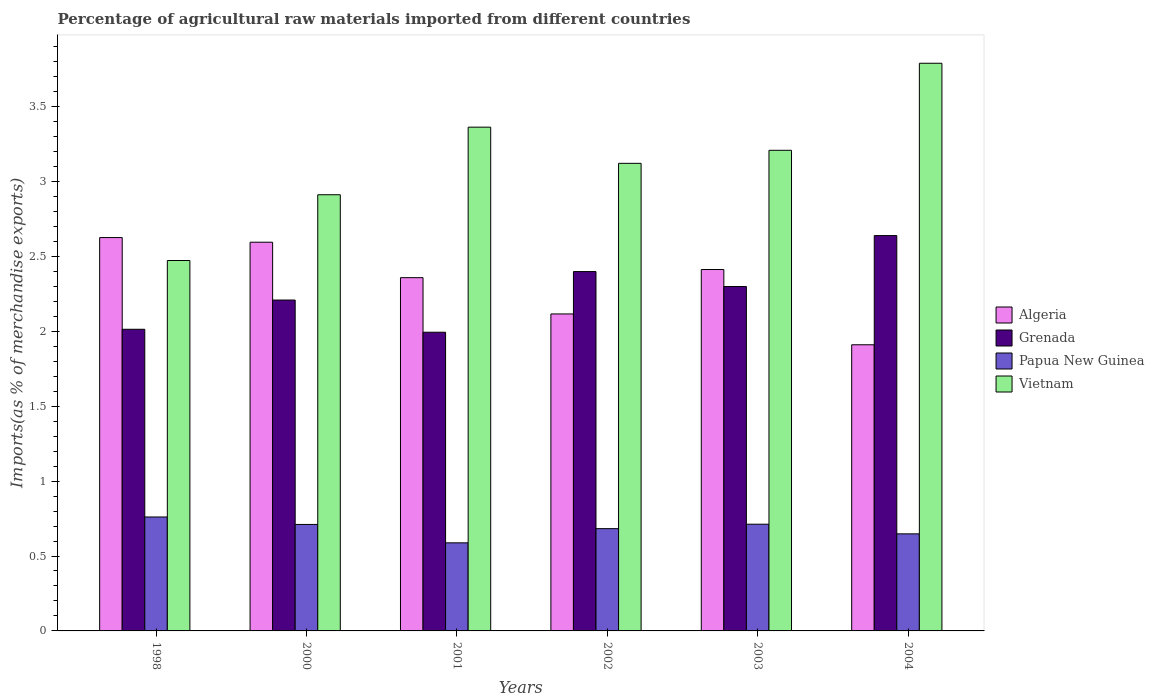How many groups of bars are there?
Provide a succinct answer. 6. Are the number of bars per tick equal to the number of legend labels?
Your response must be concise. Yes. How many bars are there on the 4th tick from the left?
Make the answer very short. 4. What is the label of the 1st group of bars from the left?
Provide a short and direct response. 1998. What is the percentage of imports to different countries in Grenada in 2004?
Keep it short and to the point. 2.64. Across all years, what is the maximum percentage of imports to different countries in Algeria?
Offer a terse response. 2.63. Across all years, what is the minimum percentage of imports to different countries in Vietnam?
Make the answer very short. 2.47. In which year was the percentage of imports to different countries in Papua New Guinea minimum?
Give a very brief answer. 2001. What is the total percentage of imports to different countries in Vietnam in the graph?
Keep it short and to the point. 18.86. What is the difference between the percentage of imports to different countries in Grenada in 2002 and that in 2004?
Offer a terse response. -0.24. What is the difference between the percentage of imports to different countries in Grenada in 2000 and the percentage of imports to different countries in Algeria in 2003?
Your answer should be compact. -0.2. What is the average percentage of imports to different countries in Algeria per year?
Provide a short and direct response. 2.34. In the year 2004, what is the difference between the percentage of imports to different countries in Papua New Guinea and percentage of imports to different countries in Grenada?
Offer a very short reply. -1.99. In how many years, is the percentage of imports to different countries in Papua New Guinea greater than 2.1 %?
Make the answer very short. 0. What is the ratio of the percentage of imports to different countries in Papua New Guinea in 2000 to that in 2002?
Ensure brevity in your answer.  1.04. Is the difference between the percentage of imports to different countries in Papua New Guinea in 1998 and 2002 greater than the difference between the percentage of imports to different countries in Grenada in 1998 and 2002?
Your answer should be compact. Yes. What is the difference between the highest and the second highest percentage of imports to different countries in Papua New Guinea?
Your answer should be very brief. 0.05. What is the difference between the highest and the lowest percentage of imports to different countries in Vietnam?
Keep it short and to the point. 1.32. What does the 3rd bar from the left in 1998 represents?
Your response must be concise. Papua New Guinea. What does the 1st bar from the right in 2001 represents?
Your answer should be compact. Vietnam. How many bars are there?
Keep it short and to the point. 24. How many years are there in the graph?
Offer a terse response. 6. Are the values on the major ticks of Y-axis written in scientific E-notation?
Ensure brevity in your answer.  No. How many legend labels are there?
Provide a short and direct response. 4. How are the legend labels stacked?
Provide a short and direct response. Vertical. What is the title of the graph?
Your response must be concise. Percentage of agricultural raw materials imported from different countries. What is the label or title of the Y-axis?
Your answer should be very brief. Imports(as % of merchandise exports). What is the Imports(as % of merchandise exports) in Algeria in 1998?
Your response must be concise. 2.63. What is the Imports(as % of merchandise exports) of Grenada in 1998?
Your response must be concise. 2.01. What is the Imports(as % of merchandise exports) of Papua New Guinea in 1998?
Give a very brief answer. 0.76. What is the Imports(as % of merchandise exports) of Vietnam in 1998?
Offer a terse response. 2.47. What is the Imports(as % of merchandise exports) in Algeria in 2000?
Offer a terse response. 2.59. What is the Imports(as % of merchandise exports) in Grenada in 2000?
Your answer should be compact. 2.21. What is the Imports(as % of merchandise exports) in Papua New Guinea in 2000?
Your answer should be very brief. 0.71. What is the Imports(as % of merchandise exports) of Vietnam in 2000?
Offer a very short reply. 2.91. What is the Imports(as % of merchandise exports) in Algeria in 2001?
Make the answer very short. 2.36. What is the Imports(as % of merchandise exports) of Grenada in 2001?
Provide a short and direct response. 1.99. What is the Imports(as % of merchandise exports) of Papua New Guinea in 2001?
Your response must be concise. 0.59. What is the Imports(as % of merchandise exports) in Vietnam in 2001?
Offer a terse response. 3.36. What is the Imports(as % of merchandise exports) of Algeria in 2002?
Provide a short and direct response. 2.12. What is the Imports(as % of merchandise exports) in Grenada in 2002?
Your answer should be very brief. 2.4. What is the Imports(as % of merchandise exports) in Papua New Guinea in 2002?
Your answer should be very brief. 0.68. What is the Imports(as % of merchandise exports) in Vietnam in 2002?
Keep it short and to the point. 3.12. What is the Imports(as % of merchandise exports) of Algeria in 2003?
Offer a terse response. 2.41. What is the Imports(as % of merchandise exports) of Grenada in 2003?
Your answer should be very brief. 2.3. What is the Imports(as % of merchandise exports) in Papua New Guinea in 2003?
Ensure brevity in your answer.  0.71. What is the Imports(as % of merchandise exports) of Vietnam in 2003?
Your answer should be very brief. 3.21. What is the Imports(as % of merchandise exports) in Algeria in 2004?
Your response must be concise. 1.91. What is the Imports(as % of merchandise exports) of Grenada in 2004?
Your answer should be very brief. 2.64. What is the Imports(as % of merchandise exports) in Papua New Guinea in 2004?
Offer a terse response. 0.65. What is the Imports(as % of merchandise exports) of Vietnam in 2004?
Give a very brief answer. 3.79. Across all years, what is the maximum Imports(as % of merchandise exports) in Algeria?
Your answer should be compact. 2.63. Across all years, what is the maximum Imports(as % of merchandise exports) in Grenada?
Give a very brief answer. 2.64. Across all years, what is the maximum Imports(as % of merchandise exports) of Papua New Guinea?
Your answer should be very brief. 0.76. Across all years, what is the maximum Imports(as % of merchandise exports) in Vietnam?
Your answer should be compact. 3.79. Across all years, what is the minimum Imports(as % of merchandise exports) in Algeria?
Give a very brief answer. 1.91. Across all years, what is the minimum Imports(as % of merchandise exports) of Grenada?
Offer a terse response. 1.99. Across all years, what is the minimum Imports(as % of merchandise exports) of Papua New Guinea?
Offer a very short reply. 0.59. Across all years, what is the minimum Imports(as % of merchandise exports) in Vietnam?
Offer a terse response. 2.47. What is the total Imports(as % of merchandise exports) in Algeria in the graph?
Your answer should be compact. 14.01. What is the total Imports(as % of merchandise exports) in Grenada in the graph?
Offer a terse response. 13.55. What is the total Imports(as % of merchandise exports) of Papua New Guinea in the graph?
Provide a short and direct response. 4.1. What is the total Imports(as % of merchandise exports) in Vietnam in the graph?
Keep it short and to the point. 18.86. What is the difference between the Imports(as % of merchandise exports) of Algeria in 1998 and that in 2000?
Offer a very short reply. 0.03. What is the difference between the Imports(as % of merchandise exports) in Grenada in 1998 and that in 2000?
Make the answer very short. -0.2. What is the difference between the Imports(as % of merchandise exports) in Papua New Guinea in 1998 and that in 2000?
Make the answer very short. 0.05. What is the difference between the Imports(as % of merchandise exports) of Vietnam in 1998 and that in 2000?
Offer a very short reply. -0.44. What is the difference between the Imports(as % of merchandise exports) of Algeria in 1998 and that in 2001?
Provide a succinct answer. 0.27. What is the difference between the Imports(as % of merchandise exports) of Grenada in 1998 and that in 2001?
Your answer should be very brief. 0.02. What is the difference between the Imports(as % of merchandise exports) in Papua New Guinea in 1998 and that in 2001?
Make the answer very short. 0.17. What is the difference between the Imports(as % of merchandise exports) of Vietnam in 1998 and that in 2001?
Provide a succinct answer. -0.89. What is the difference between the Imports(as % of merchandise exports) in Algeria in 1998 and that in 2002?
Offer a terse response. 0.51. What is the difference between the Imports(as % of merchandise exports) in Grenada in 1998 and that in 2002?
Ensure brevity in your answer.  -0.39. What is the difference between the Imports(as % of merchandise exports) of Papua New Guinea in 1998 and that in 2002?
Offer a terse response. 0.08. What is the difference between the Imports(as % of merchandise exports) of Vietnam in 1998 and that in 2002?
Offer a very short reply. -0.65. What is the difference between the Imports(as % of merchandise exports) in Algeria in 1998 and that in 2003?
Ensure brevity in your answer.  0.21. What is the difference between the Imports(as % of merchandise exports) of Grenada in 1998 and that in 2003?
Provide a short and direct response. -0.29. What is the difference between the Imports(as % of merchandise exports) in Papua New Guinea in 1998 and that in 2003?
Give a very brief answer. 0.05. What is the difference between the Imports(as % of merchandise exports) in Vietnam in 1998 and that in 2003?
Your response must be concise. -0.74. What is the difference between the Imports(as % of merchandise exports) in Algeria in 1998 and that in 2004?
Your response must be concise. 0.72. What is the difference between the Imports(as % of merchandise exports) of Grenada in 1998 and that in 2004?
Give a very brief answer. -0.63. What is the difference between the Imports(as % of merchandise exports) of Papua New Guinea in 1998 and that in 2004?
Make the answer very short. 0.11. What is the difference between the Imports(as % of merchandise exports) in Vietnam in 1998 and that in 2004?
Offer a very short reply. -1.32. What is the difference between the Imports(as % of merchandise exports) of Algeria in 2000 and that in 2001?
Ensure brevity in your answer.  0.24. What is the difference between the Imports(as % of merchandise exports) of Grenada in 2000 and that in 2001?
Keep it short and to the point. 0.21. What is the difference between the Imports(as % of merchandise exports) in Papua New Guinea in 2000 and that in 2001?
Your answer should be compact. 0.12. What is the difference between the Imports(as % of merchandise exports) in Vietnam in 2000 and that in 2001?
Your answer should be compact. -0.45. What is the difference between the Imports(as % of merchandise exports) in Algeria in 2000 and that in 2002?
Give a very brief answer. 0.48. What is the difference between the Imports(as % of merchandise exports) of Grenada in 2000 and that in 2002?
Provide a succinct answer. -0.19. What is the difference between the Imports(as % of merchandise exports) of Papua New Guinea in 2000 and that in 2002?
Your response must be concise. 0.03. What is the difference between the Imports(as % of merchandise exports) of Vietnam in 2000 and that in 2002?
Make the answer very short. -0.21. What is the difference between the Imports(as % of merchandise exports) of Algeria in 2000 and that in 2003?
Keep it short and to the point. 0.18. What is the difference between the Imports(as % of merchandise exports) of Grenada in 2000 and that in 2003?
Keep it short and to the point. -0.09. What is the difference between the Imports(as % of merchandise exports) of Papua New Guinea in 2000 and that in 2003?
Keep it short and to the point. -0. What is the difference between the Imports(as % of merchandise exports) of Vietnam in 2000 and that in 2003?
Your response must be concise. -0.3. What is the difference between the Imports(as % of merchandise exports) of Algeria in 2000 and that in 2004?
Keep it short and to the point. 0.68. What is the difference between the Imports(as % of merchandise exports) of Grenada in 2000 and that in 2004?
Make the answer very short. -0.43. What is the difference between the Imports(as % of merchandise exports) of Papua New Guinea in 2000 and that in 2004?
Keep it short and to the point. 0.06. What is the difference between the Imports(as % of merchandise exports) in Vietnam in 2000 and that in 2004?
Your response must be concise. -0.88. What is the difference between the Imports(as % of merchandise exports) of Algeria in 2001 and that in 2002?
Ensure brevity in your answer.  0.24. What is the difference between the Imports(as % of merchandise exports) of Grenada in 2001 and that in 2002?
Your answer should be compact. -0.4. What is the difference between the Imports(as % of merchandise exports) of Papua New Guinea in 2001 and that in 2002?
Your answer should be compact. -0.09. What is the difference between the Imports(as % of merchandise exports) of Vietnam in 2001 and that in 2002?
Ensure brevity in your answer.  0.24. What is the difference between the Imports(as % of merchandise exports) of Algeria in 2001 and that in 2003?
Ensure brevity in your answer.  -0.05. What is the difference between the Imports(as % of merchandise exports) in Grenada in 2001 and that in 2003?
Provide a short and direct response. -0.31. What is the difference between the Imports(as % of merchandise exports) of Papua New Guinea in 2001 and that in 2003?
Your answer should be very brief. -0.12. What is the difference between the Imports(as % of merchandise exports) of Vietnam in 2001 and that in 2003?
Offer a terse response. 0.15. What is the difference between the Imports(as % of merchandise exports) in Algeria in 2001 and that in 2004?
Your response must be concise. 0.45. What is the difference between the Imports(as % of merchandise exports) in Grenada in 2001 and that in 2004?
Provide a short and direct response. -0.65. What is the difference between the Imports(as % of merchandise exports) in Papua New Guinea in 2001 and that in 2004?
Provide a succinct answer. -0.06. What is the difference between the Imports(as % of merchandise exports) in Vietnam in 2001 and that in 2004?
Offer a terse response. -0.43. What is the difference between the Imports(as % of merchandise exports) in Algeria in 2002 and that in 2003?
Your response must be concise. -0.3. What is the difference between the Imports(as % of merchandise exports) in Grenada in 2002 and that in 2003?
Your answer should be very brief. 0.1. What is the difference between the Imports(as % of merchandise exports) of Papua New Guinea in 2002 and that in 2003?
Make the answer very short. -0.03. What is the difference between the Imports(as % of merchandise exports) in Vietnam in 2002 and that in 2003?
Provide a short and direct response. -0.09. What is the difference between the Imports(as % of merchandise exports) of Algeria in 2002 and that in 2004?
Your answer should be compact. 0.21. What is the difference between the Imports(as % of merchandise exports) of Grenada in 2002 and that in 2004?
Offer a very short reply. -0.24. What is the difference between the Imports(as % of merchandise exports) in Papua New Guinea in 2002 and that in 2004?
Your response must be concise. 0.03. What is the difference between the Imports(as % of merchandise exports) of Vietnam in 2002 and that in 2004?
Provide a succinct answer. -0.67. What is the difference between the Imports(as % of merchandise exports) in Algeria in 2003 and that in 2004?
Offer a terse response. 0.5. What is the difference between the Imports(as % of merchandise exports) in Grenada in 2003 and that in 2004?
Your answer should be very brief. -0.34. What is the difference between the Imports(as % of merchandise exports) of Papua New Guinea in 2003 and that in 2004?
Give a very brief answer. 0.06. What is the difference between the Imports(as % of merchandise exports) of Vietnam in 2003 and that in 2004?
Offer a terse response. -0.58. What is the difference between the Imports(as % of merchandise exports) in Algeria in 1998 and the Imports(as % of merchandise exports) in Grenada in 2000?
Provide a succinct answer. 0.42. What is the difference between the Imports(as % of merchandise exports) in Algeria in 1998 and the Imports(as % of merchandise exports) in Papua New Guinea in 2000?
Provide a succinct answer. 1.91. What is the difference between the Imports(as % of merchandise exports) of Algeria in 1998 and the Imports(as % of merchandise exports) of Vietnam in 2000?
Your answer should be very brief. -0.29. What is the difference between the Imports(as % of merchandise exports) of Grenada in 1998 and the Imports(as % of merchandise exports) of Papua New Guinea in 2000?
Ensure brevity in your answer.  1.3. What is the difference between the Imports(as % of merchandise exports) of Grenada in 1998 and the Imports(as % of merchandise exports) of Vietnam in 2000?
Give a very brief answer. -0.9. What is the difference between the Imports(as % of merchandise exports) in Papua New Guinea in 1998 and the Imports(as % of merchandise exports) in Vietnam in 2000?
Offer a terse response. -2.15. What is the difference between the Imports(as % of merchandise exports) in Algeria in 1998 and the Imports(as % of merchandise exports) in Grenada in 2001?
Ensure brevity in your answer.  0.63. What is the difference between the Imports(as % of merchandise exports) of Algeria in 1998 and the Imports(as % of merchandise exports) of Papua New Guinea in 2001?
Ensure brevity in your answer.  2.04. What is the difference between the Imports(as % of merchandise exports) in Algeria in 1998 and the Imports(as % of merchandise exports) in Vietnam in 2001?
Ensure brevity in your answer.  -0.74. What is the difference between the Imports(as % of merchandise exports) in Grenada in 1998 and the Imports(as % of merchandise exports) in Papua New Guinea in 2001?
Give a very brief answer. 1.43. What is the difference between the Imports(as % of merchandise exports) in Grenada in 1998 and the Imports(as % of merchandise exports) in Vietnam in 2001?
Provide a succinct answer. -1.35. What is the difference between the Imports(as % of merchandise exports) in Papua New Guinea in 1998 and the Imports(as % of merchandise exports) in Vietnam in 2001?
Give a very brief answer. -2.6. What is the difference between the Imports(as % of merchandise exports) of Algeria in 1998 and the Imports(as % of merchandise exports) of Grenada in 2002?
Your answer should be very brief. 0.23. What is the difference between the Imports(as % of merchandise exports) in Algeria in 1998 and the Imports(as % of merchandise exports) in Papua New Guinea in 2002?
Keep it short and to the point. 1.94. What is the difference between the Imports(as % of merchandise exports) in Algeria in 1998 and the Imports(as % of merchandise exports) in Vietnam in 2002?
Your answer should be compact. -0.5. What is the difference between the Imports(as % of merchandise exports) in Grenada in 1998 and the Imports(as % of merchandise exports) in Papua New Guinea in 2002?
Ensure brevity in your answer.  1.33. What is the difference between the Imports(as % of merchandise exports) in Grenada in 1998 and the Imports(as % of merchandise exports) in Vietnam in 2002?
Provide a succinct answer. -1.11. What is the difference between the Imports(as % of merchandise exports) in Papua New Guinea in 1998 and the Imports(as % of merchandise exports) in Vietnam in 2002?
Give a very brief answer. -2.36. What is the difference between the Imports(as % of merchandise exports) of Algeria in 1998 and the Imports(as % of merchandise exports) of Grenada in 2003?
Make the answer very short. 0.33. What is the difference between the Imports(as % of merchandise exports) in Algeria in 1998 and the Imports(as % of merchandise exports) in Papua New Guinea in 2003?
Offer a terse response. 1.91. What is the difference between the Imports(as % of merchandise exports) in Algeria in 1998 and the Imports(as % of merchandise exports) in Vietnam in 2003?
Provide a succinct answer. -0.58. What is the difference between the Imports(as % of merchandise exports) in Grenada in 1998 and the Imports(as % of merchandise exports) in Papua New Guinea in 2003?
Your answer should be very brief. 1.3. What is the difference between the Imports(as % of merchandise exports) of Grenada in 1998 and the Imports(as % of merchandise exports) of Vietnam in 2003?
Your answer should be compact. -1.19. What is the difference between the Imports(as % of merchandise exports) of Papua New Guinea in 1998 and the Imports(as % of merchandise exports) of Vietnam in 2003?
Your response must be concise. -2.45. What is the difference between the Imports(as % of merchandise exports) of Algeria in 1998 and the Imports(as % of merchandise exports) of Grenada in 2004?
Keep it short and to the point. -0.01. What is the difference between the Imports(as % of merchandise exports) in Algeria in 1998 and the Imports(as % of merchandise exports) in Papua New Guinea in 2004?
Keep it short and to the point. 1.98. What is the difference between the Imports(as % of merchandise exports) of Algeria in 1998 and the Imports(as % of merchandise exports) of Vietnam in 2004?
Keep it short and to the point. -1.16. What is the difference between the Imports(as % of merchandise exports) in Grenada in 1998 and the Imports(as % of merchandise exports) in Papua New Guinea in 2004?
Offer a very short reply. 1.37. What is the difference between the Imports(as % of merchandise exports) of Grenada in 1998 and the Imports(as % of merchandise exports) of Vietnam in 2004?
Offer a very short reply. -1.78. What is the difference between the Imports(as % of merchandise exports) in Papua New Guinea in 1998 and the Imports(as % of merchandise exports) in Vietnam in 2004?
Ensure brevity in your answer.  -3.03. What is the difference between the Imports(as % of merchandise exports) in Algeria in 2000 and the Imports(as % of merchandise exports) in Grenada in 2001?
Your response must be concise. 0.6. What is the difference between the Imports(as % of merchandise exports) of Algeria in 2000 and the Imports(as % of merchandise exports) of Papua New Guinea in 2001?
Make the answer very short. 2.01. What is the difference between the Imports(as % of merchandise exports) in Algeria in 2000 and the Imports(as % of merchandise exports) in Vietnam in 2001?
Ensure brevity in your answer.  -0.77. What is the difference between the Imports(as % of merchandise exports) in Grenada in 2000 and the Imports(as % of merchandise exports) in Papua New Guinea in 2001?
Your answer should be compact. 1.62. What is the difference between the Imports(as % of merchandise exports) in Grenada in 2000 and the Imports(as % of merchandise exports) in Vietnam in 2001?
Your response must be concise. -1.15. What is the difference between the Imports(as % of merchandise exports) of Papua New Guinea in 2000 and the Imports(as % of merchandise exports) of Vietnam in 2001?
Your answer should be very brief. -2.65. What is the difference between the Imports(as % of merchandise exports) in Algeria in 2000 and the Imports(as % of merchandise exports) in Grenada in 2002?
Keep it short and to the point. 0.2. What is the difference between the Imports(as % of merchandise exports) of Algeria in 2000 and the Imports(as % of merchandise exports) of Papua New Guinea in 2002?
Ensure brevity in your answer.  1.91. What is the difference between the Imports(as % of merchandise exports) in Algeria in 2000 and the Imports(as % of merchandise exports) in Vietnam in 2002?
Your answer should be very brief. -0.53. What is the difference between the Imports(as % of merchandise exports) in Grenada in 2000 and the Imports(as % of merchandise exports) in Papua New Guinea in 2002?
Make the answer very short. 1.53. What is the difference between the Imports(as % of merchandise exports) of Grenada in 2000 and the Imports(as % of merchandise exports) of Vietnam in 2002?
Provide a short and direct response. -0.91. What is the difference between the Imports(as % of merchandise exports) of Papua New Guinea in 2000 and the Imports(as % of merchandise exports) of Vietnam in 2002?
Offer a terse response. -2.41. What is the difference between the Imports(as % of merchandise exports) of Algeria in 2000 and the Imports(as % of merchandise exports) of Grenada in 2003?
Your answer should be very brief. 0.3. What is the difference between the Imports(as % of merchandise exports) in Algeria in 2000 and the Imports(as % of merchandise exports) in Papua New Guinea in 2003?
Offer a terse response. 1.88. What is the difference between the Imports(as % of merchandise exports) in Algeria in 2000 and the Imports(as % of merchandise exports) in Vietnam in 2003?
Offer a very short reply. -0.61. What is the difference between the Imports(as % of merchandise exports) of Grenada in 2000 and the Imports(as % of merchandise exports) of Papua New Guinea in 2003?
Your answer should be very brief. 1.5. What is the difference between the Imports(as % of merchandise exports) in Grenada in 2000 and the Imports(as % of merchandise exports) in Vietnam in 2003?
Give a very brief answer. -1. What is the difference between the Imports(as % of merchandise exports) in Papua New Guinea in 2000 and the Imports(as % of merchandise exports) in Vietnam in 2003?
Give a very brief answer. -2.5. What is the difference between the Imports(as % of merchandise exports) of Algeria in 2000 and the Imports(as % of merchandise exports) of Grenada in 2004?
Give a very brief answer. -0.04. What is the difference between the Imports(as % of merchandise exports) of Algeria in 2000 and the Imports(as % of merchandise exports) of Papua New Guinea in 2004?
Your answer should be compact. 1.95. What is the difference between the Imports(as % of merchandise exports) of Algeria in 2000 and the Imports(as % of merchandise exports) of Vietnam in 2004?
Give a very brief answer. -1.19. What is the difference between the Imports(as % of merchandise exports) in Grenada in 2000 and the Imports(as % of merchandise exports) in Papua New Guinea in 2004?
Your answer should be very brief. 1.56. What is the difference between the Imports(as % of merchandise exports) in Grenada in 2000 and the Imports(as % of merchandise exports) in Vietnam in 2004?
Provide a succinct answer. -1.58. What is the difference between the Imports(as % of merchandise exports) in Papua New Guinea in 2000 and the Imports(as % of merchandise exports) in Vietnam in 2004?
Provide a short and direct response. -3.08. What is the difference between the Imports(as % of merchandise exports) in Algeria in 2001 and the Imports(as % of merchandise exports) in Grenada in 2002?
Provide a succinct answer. -0.04. What is the difference between the Imports(as % of merchandise exports) in Algeria in 2001 and the Imports(as % of merchandise exports) in Papua New Guinea in 2002?
Your answer should be compact. 1.68. What is the difference between the Imports(as % of merchandise exports) in Algeria in 2001 and the Imports(as % of merchandise exports) in Vietnam in 2002?
Make the answer very short. -0.76. What is the difference between the Imports(as % of merchandise exports) of Grenada in 2001 and the Imports(as % of merchandise exports) of Papua New Guinea in 2002?
Give a very brief answer. 1.31. What is the difference between the Imports(as % of merchandise exports) of Grenada in 2001 and the Imports(as % of merchandise exports) of Vietnam in 2002?
Your answer should be very brief. -1.13. What is the difference between the Imports(as % of merchandise exports) of Papua New Guinea in 2001 and the Imports(as % of merchandise exports) of Vietnam in 2002?
Keep it short and to the point. -2.53. What is the difference between the Imports(as % of merchandise exports) in Algeria in 2001 and the Imports(as % of merchandise exports) in Grenada in 2003?
Provide a short and direct response. 0.06. What is the difference between the Imports(as % of merchandise exports) in Algeria in 2001 and the Imports(as % of merchandise exports) in Papua New Guinea in 2003?
Your response must be concise. 1.65. What is the difference between the Imports(as % of merchandise exports) in Algeria in 2001 and the Imports(as % of merchandise exports) in Vietnam in 2003?
Offer a terse response. -0.85. What is the difference between the Imports(as % of merchandise exports) of Grenada in 2001 and the Imports(as % of merchandise exports) of Papua New Guinea in 2003?
Provide a succinct answer. 1.28. What is the difference between the Imports(as % of merchandise exports) of Grenada in 2001 and the Imports(as % of merchandise exports) of Vietnam in 2003?
Your response must be concise. -1.21. What is the difference between the Imports(as % of merchandise exports) in Papua New Guinea in 2001 and the Imports(as % of merchandise exports) in Vietnam in 2003?
Keep it short and to the point. -2.62. What is the difference between the Imports(as % of merchandise exports) in Algeria in 2001 and the Imports(as % of merchandise exports) in Grenada in 2004?
Give a very brief answer. -0.28. What is the difference between the Imports(as % of merchandise exports) in Algeria in 2001 and the Imports(as % of merchandise exports) in Papua New Guinea in 2004?
Ensure brevity in your answer.  1.71. What is the difference between the Imports(as % of merchandise exports) of Algeria in 2001 and the Imports(as % of merchandise exports) of Vietnam in 2004?
Your response must be concise. -1.43. What is the difference between the Imports(as % of merchandise exports) in Grenada in 2001 and the Imports(as % of merchandise exports) in Papua New Guinea in 2004?
Ensure brevity in your answer.  1.35. What is the difference between the Imports(as % of merchandise exports) in Grenada in 2001 and the Imports(as % of merchandise exports) in Vietnam in 2004?
Your answer should be very brief. -1.8. What is the difference between the Imports(as % of merchandise exports) of Papua New Guinea in 2001 and the Imports(as % of merchandise exports) of Vietnam in 2004?
Provide a succinct answer. -3.2. What is the difference between the Imports(as % of merchandise exports) of Algeria in 2002 and the Imports(as % of merchandise exports) of Grenada in 2003?
Ensure brevity in your answer.  -0.18. What is the difference between the Imports(as % of merchandise exports) in Algeria in 2002 and the Imports(as % of merchandise exports) in Papua New Guinea in 2003?
Your answer should be very brief. 1.4. What is the difference between the Imports(as % of merchandise exports) in Algeria in 2002 and the Imports(as % of merchandise exports) in Vietnam in 2003?
Offer a very short reply. -1.09. What is the difference between the Imports(as % of merchandise exports) in Grenada in 2002 and the Imports(as % of merchandise exports) in Papua New Guinea in 2003?
Provide a succinct answer. 1.69. What is the difference between the Imports(as % of merchandise exports) in Grenada in 2002 and the Imports(as % of merchandise exports) in Vietnam in 2003?
Your response must be concise. -0.81. What is the difference between the Imports(as % of merchandise exports) of Papua New Guinea in 2002 and the Imports(as % of merchandise exports) of Vietnam in 2003?
Keep it short and to the point. -2.52. What is the difference between the Imports(as % of merchandise exports) in Algeria in 2002 and the Imports(as % of merchandise exports) in Grenada in 2004?
Keep it short and to the point. -0.52. What is the difference between the Imports(as % of merchandise exports) of Algeria in 2002 and the Imports(as % of merchandise exports) of Papua New Guinea in 2004?
Your response must be concise. 1.47. What is the difference between the Imports(as % of merchandise exports) in Algeria in 2002 and the Imports(as % of merchandise exports) in Vietnam in 2004?
Your answer should be compact. -1.67. What is the difference between the Imports(as % of merchandise exports) in Grenada in 2002 and the Imports(as % of merchandise exports) in Papua New Guinea in 2004?
Ensure brevity in your answer.  1.75. What is the difference between the Imports(as % of merchandise exports) in Grenada in 2002 and the Imports(as % of merchandise exports) in Vietnam in 2004?
Offer a terse response. -1.39. What is the difference between the Imports(as % of merchandise exports) in Papua New Guinea in 2002 and the Imports(as % of merchandise exports) in Vietnam in 2004?
Ensure brevity in your answer.  -3.11. What is the difference between the Imports(as % of merchandise exports) in Algeria in 2003 and the Imports(as % of merchandise exports) in Grenada in 2004?
Keep it short and to the point. -0.23. What is the difference between the Imports(as % of merchandise exports) in Algeria in 2003 and the Imports(as % of merchandise exports) in Papua New Guinea in 2004?
Offer a very short reply. 1.76. What is the difference between the Imports(as % of merchandise exports) in Algeria in 2003 and the Imports(as % of merchandise exports) in Vietnam in 2004?
Your response must be concise. -1.38. What is the difference between the Imports(as % of merchandise exports) in Grenada in 2003 and the Imports(as % of merchandise exports) in Papua New Guinea in 2004?
Offer a terse response. 1.65. What is the difference between the Imports(as % of merchandise exports) in Grenada in 2003 and the Imports(as % of merchandise exports) in Vietnam in 2004?
Your answer should be very brief. -1.49. What is the difference between the Imports(as % of merchandise exports) of Papua New Guinea in 2003 and the Imports(as % of merchandise exports) of Vietnam in 2004?
Offer a very short reply. -3.08. What is the average Imports(as % of merchandise exports) of Algeria per year?
Provide a succinct answer. 2.34. What is the average Imports(as % of merchandise exports) in Grenada per year?
Ensure brevity in your answer.  2.26. What is the average Imports(as % of merchandise exports) of Papua New Guinea per year?
Ensure brevity in your answer.  0.68. What is the average Imports(as % of merchandise exports) in Vietnam per year?
Keep it short and to the point. 3.14. In the year 1998, what is the difference between the Imports(as % of merchandise exports) in Algeria and Imports(as % of merchandise exports) in Grenada?
Keep it short and to the point. 0.61. In the year 1998, what is the difference between the Imports(as % of merchandise exports) in Algeria and Imports(as % of merchandise exports) in Papua New Guinea?
Your answer should be very brief. 1.86. In the year 1998, what is the difference between the Imports(as % of merchandise exports) in Algeria and Imports(as % of merchandise exports) in Vietnam?
Your answer should be very brief. 0.15. In the year 1998, what is the difference between the Imports(as % of merchandise exports) in Grenada and Imports(as % of merchandise exports) in Papua New Guinea?
Make the answer very short. 1.25. In the year 1998, what is the difference between the Imports(as % of merchandise exports) of Grenada and Imports(as % of merchandise exports) of Vietnam?
Your answer should be very brief. -0.46. In the year 1998, what is the difference between the Imports(as % of merchandise exports) in Papua New Guinea and Imports(as % of merchandise exports) in Vietnam?
Ensure brevity in your answer.  -1.71. In the year 2000, what is the difference between the Imports(as % of merchandise exports) in Algeria and Imports(as % of merchandise exports) in Grenada?
Your response must be concise. 0.39. In the year 2000, what is the difference between the Imports(as % of merchandise exports) of Algeria and Imports(as % of merchandise exports) of Papua New Guinea?
Your response must be concise. 1.88. In the year 2000, what is the difference between the Imports(as % of merchandise exports) of Algeria and Imports(as % of merchandise exports) of Vietnam?
Your answer should be compact. -0.32. In the year 2000, what is the difference between the Imports(as % of merchandise exports) in Grenada and Imports(as % of merchandise exports) in Papua New Guinea?
Your response must be concise. 1.5. In the year 2000, what is the difference between the Imports(as % of merchandise exports) in Grenada and Imports(as % of merchandise exports) in Vietnam?
Your answer should be compact. -0.7. In the year 2000, what is the difference between the Imports(as % of merchandise exports) in Papua New Guinea and Imports(as % of merchandise exports) in Vietnam?
Offer a very short reply. -2.2. In the year 2001, what is the difference between the Imports(as % of merchandise exports) in Algeria and Imports(as % of merchandise exports) in Grenada?
Your answer should be compact. 0.36. In the year 2001, what is the difference between the Imports(as % of merchandise exports) of Algeria and Imports(as % of merchandise exports) of Papua New Guinea?
Your answer should be compact. 1.77. In the year 2001, what is the difference between the Imports(as % of merchandise exports) of Algeria and Imports(as % of merchandise exports) of Vietnam?
Give a very brief answer. -1. In the year 2001, what is the difference between the Imports(as % of merchandise exports) in Grenada and Imports(as % of merchandise exports) in Papua New Guinea?
Make the answer very short. 1.41. In the year 2001, what is the difference between the Imports(as % of merchandise exports) of Grenada and Imports(as % of merchandise exports) of Vietnam?
Offer a very short reply. -1.37. In the year 2001, what is the difference between the Imports(as % of merchandise exports) in Papua New Guinea and Imports(as % of merchandise exports) in Vietnam?
Offer a very short reply. -2.77. In the year 2002, what is the difference between the Imports(as % of merchandise exports) in Algeria and Imports(as % of merchandise exports) in Grenada?
Make the answer very short. -0.28. In the year 2002, what is the difference between the Imports(as % of merchandise exports) of Algeria and Imports(as % of merchandise exports) of Papua New Guinea?
Give a very brief answer. 1.43. In the year 2002, what is the difference between the Imports(as % of merchandise exports) in Algeria and Imports(as % of merchandise exports) in Vietnam?
Make the answer very short. -1.01. In the year 2002, what is the difference between the Imports(as % of merchandise exports) of Grenada and Imports(as % of merchandise exports) of Papua New Guinea?
Your answer should be compact. 1.72. In the year 2002, what is the difference between the Imports(as % of merchandise exports) in Grenada and Imports(as % of merchandise exports) in Vietnam?
Your response must be concise. -0.72. In the year 2002, what is the difference between the Imports(as % of merchandise exports) in Papua New Guinea and Imports(as % of merchandise exports) in Vietnam?
Ensure brevity in your answer.  -2.44. In the year 2003, what is the difference between the Imports(as % of merchandise exports) in Algeria and Imports(as % of merchandise exports) in Grenada?
Provide a short and direct response. 0.11. In the year 2003, what is the difference between the Imports(as % of merchandise exports) in Algeria and Imports(as % of merchandise exports) in Papua New Guinea?
Provide a short and direct response. 1.7. In the year 2003, what is the difference between the Imports(as % of merchandise exports) of Algeria and Imports(as % of merchandise exports) of Vietnam?
Provide a succinct answer. -0.8. In the year 2003, what is the difference between the Imports(as % of merchandise exports) of Grenada and Imports(as % of merchandise exports) of Papua New Guinea?
Your answer should be compact. 1.59. In the year 2003, what is the difference between the Imports(as % of merchandise exports) in Grenada and Imports(as % of merchandise exports) in Vietnam?
Your answer should be compact. -0.91. In the year 2003, what is the difference between the Imports(as % of merchandise exports) of Papua New Guinea and Imports(as % of merchandise exports) of Vietnam?
Ensure brevity in your answer.  -2.5. In the year 2004, what is the difference between the Imports(as % of merchandise exports) in Algeria and Imports(as % of merchandise exports) in Grenada?
Provide a short and direct response. -0.73. In the year 2004, what is the difference between the Imports(as % of merchandise exports) in Algeria and Imports(as % of merchandise exports) in Papua New Guinea?
Your answer should be very brief. 1.26. In the year 2004, what is the difference between the Imports(as % of merchandise exports) in Algeria and Imports(as % of merchandise exports) in Vietnam?
Your response must be concise. -1.88. In the year 2004, what is the difference between the Imports(as % of merchandise exports) in Grenada and Imports(as % of merchandise exports) in Papua New Guinea?
Your answer should be very brief. 1.99. In the year 2004, what is the difference between the Imports(as % of merchandise exports) of Grenada and Imports(as % of merchandise exports) of Vietnam?
Provide a succinct answer. -1.15. In the year 2004, what is the difference between the Imports(as % of merchandise exports) of Papua New Guinea and Imports(as % of merchandise exports) of Vietnam?
Give a very brief answer. -3.14. What is the ratio of the Imports(as % of merchandise exports) of Algeria in 1998 to that in 2000?
Offer a terse response. 1.01. What is the ratio of the Imports(as % of merchandise exports) in Grenada in 1998 to that in 2000?
Keep it short and to the point. 0.91. What is the ratio of the Imports(as % of merchandise exports) of Papua New Guinea in 1998 to that in 2000?
Give a very brief answer. 1.07. What is the ratio of the Imports(as % of merchandise exports) of Vietnam in 1998 to that in 2000?
Your answer should be very brief. 0.85. What is the ratio of the Imports(as % of merchandise exports) in Algeria in 1998 to that in 2001?
Your answer should be compact. 1.11. What is the ratio of the Imports(as % of merchandise exports) of Grenada in 1998 to that in 2001?
Your answer should be very brief. 1.01. What is the ratio of the Imports(as % of merchandise exports) in Papua New Guinea in 1998 to that in 2001?
Keep it short and to the point. 1.29. What is the ratio of the Imports(as % of merchandise exports) of Vietnam in 1998 to that in 2001?
Your answer should be compact. 0.74. What is the ratio of the Imports(as % of merchandise exports) of Algeria in 1998 to that in 2002?
Your answer should be compact. 1.24. What is the ratio of the Imports(as % of merchandise exports) in Grenada in 1998 to that in 2002?
Your answer should be compact. 0.84. What is the ratio of the Imports(as % of merchandise exports) of Papua New Guinea in 1998 to that in 2002?
Provide a short and direct response. 1.11. What is the ratio of the Imports(as % of merchandise exports) of Vietnam in 1998 to that in 2002?
Offer a very short reply. 0.79. What is the ratio of the Imports(as % of merchandise exports) of Algeria in 1998 to that in 2003?
Offer a very short reply. 1.09. What is the ratio of the Imports(as % of merchandise exports) of Grenada in 1998 to that in 2003?
Provide a succinct answer. 0.88. What is the ratio of the Imports(as % of merchandise exports) of Papua New Guinea in 1998 to that in 2003?
Ensure brevity in your answer.  1.07. What is the ratio of the Imports(as % of merchandise exports) of Vietnam in 1998 to that in 2003?
Provide a succinct answer. 0.77. What is the ratio of the Imports(as % of merchandise exports) of Algeria in 1998 to that in 2004?
Keep it short and to the point. 1.37. What is the ratio of the Imports(as % of merchandise exports) of Grenada in 1998 to that in 2004?
Offer a very short reply. 0.76. What is the ratio of the Imports(as % of merchandise exports) of Papua New Guinea in 1998 to that in 2004?
Your response must be concise. 1.17. What is the ratio of the Imports(as % of merchandise exports) in Vietnam in 1998 to that in 2004?
Provide a succinct answer. 0.65. What is the ratio of the Imports(as % of merchandise exports) in Algeria in 2000 to that in 2001?
Your response must be concise. 1.1. What is the ratio of the Imports(as % of merchandise exports) of Grenada in 2000 to that in 2001?
Ensure brevity in your answer.  1.11. What is the ratio of the Imports(as % of merchandise exports) in Papua New Guinea in 2000 to that in 2001?
Ensure brevity in your answer.  1.21. What is the ratio of the Imports(as % of merchandise exports) of Vietnam in 2000 to that in 2001?
Provide a succinct answer. 0.87. What is the ratio of the Imports(as % of merchandise exports) of Algeria in 2000 to that in 2002?
Provide a succinct answer. 1.23. What is the ratio of the Imports(as % of merchandise exports) in Grenada in 2000 to that in 2002?
Give a very brief answer. 0.92. What is the ratio of the Imports(as % of merchandise exports) in Papua New Guinea in 2000 to that in 2002?
Offer a terse response. 1.04. What is the ratio of the Imports(as % of merchandise exports) in Vietnam in 2000 to that in 2002?
Give a very brief answer. 0.93. What is the ratio of the Imports(as % of merchandise exports) of Algeria in 2000 to that in 2003?
Make the answer very short. 1.08. What is the ratio of the Imports(as % of merchandise exports) in Grenada in 2000 to that in 2003?
Provide a succinct answer. 0.96. What is the ratio of the Imports(as % of merchandise exports) in Papua New Guinea in 2000 to that in 2003?
Your answer should be very brief. 1. What is the ratio of the Imports(as % of merchandise exports) in Vietnam in 2000 to that in 2003?
Provide a short and direct response. 0.91. What is the ratio of the Imports(as % of merchandise exports) of Algeria in 2000 to that in 2004?
Your answer should be compact. 1.36. What is the ratio of the Imports(as % of merchandise exports) of Grenada in 2000 to that in 2004?
Your answer should be very brief. 0.84. What is the ratio of the Imports(as % of merchandise exports) of Papua New Guinea in 2000 to that in 2004?
Ensure brevity in your answer.  1.1. What is the ratio of the Imports(as % of merchandise exports) of Vietnam in 2000 to that in 2004?
Offer a terse response. 0.77. What is the ratio of the Imports(as % of merchandise exports) in Algeria in 2001 to that in 2002?
Offer a terse response. 1.11. What is the ratio of the Imports(as % of merchandise exports) of Grenada in 2001 to that in 2002?
Provide a succinct answer. 0.83. What is the ratio of the Imports(as % of merchandise exports) in Papua New Guinea in 2001 to that in 2002?
Your response must be concise. 0.86. What is the ratio of the Imports(as % of merchandise exports) in Vietnam in 2001 to that in 2002?
Give a very brief answer. 1.08. What is the ratio of the Imports(as % of merchandise exports) of Algeria in 2001 to that in 2003?
Your answer should be compact. 0.98. What is the ratio of the Imports(as % of merchandise exports) of Grenada in 2001 to that in 2003?
Offer a very short reply. 0.87. What is the ratio of the Imports(as % of merchandise exports) of Papua New Guinea in 2001 to that in 2003?
Your response must be concise. 0.83. What is the ratio of the Imports(as % of merchandise exports) in Vietnam in 2001 to that in 2003?
Your answer should be very brief. 1.05. What is the ratio of the Imports(as % of merchandise exports) in Algeria in 2001 to that in 2004?
Ensure brevity in your answer.  1.23. What is the ratio of the Imports(as % of merchandise exports) of Grenada in 2001 to that in 2004?
Your response must be concise. 0.76. What is the ratio of the Imports(as % of merchandise exports) of Papua New Guinea in 2001 to that in 2004?
Give a very brief answer. 0.91. What is the ratio of the Imports(as % of merchandise exports) of Vietnam in 2001 to that in 2004?
Offer a very short reply. 0.89. What is the ratio of the Imports(as % of merchandise exports) of Algeria in 2002 to that in 2003?
Your answer should be compact. 0.88. What is the ratio of the Imports(as % of merchandise exports) of Grenada in 2002 to that in 2003?
Offer a terse response. 1.04. What is the ratio of the Imports(as % of merchandise exports) in Vietnam in 2002 to that in 2003?
Provide a succinct answer. 0.97. What is the ratio of the Imports(as % of merchandise exports) of Algeria in 2002 to that in 2004?
Provide a short and direct response. 1.11. What is the ratio of the Imports(as % of merchandise exports) in Grenada in 2002 to that in 2004?
Your answer should be compact. 0.91. What is the ratio of the Imports(as % of merchandise exports) in Papua New Guinea in 2002 to that in 2004?
Give a very brief answer. 1.05. What is the ratio of the Imports(as % of merchandise exports) in Vietnam in 2002 to that in 2004?
Your response must be concise. 0.82. What is the ratio of the Imports(as % of merchandise exports) of Algeria in 2003 to that in 2004?
Provide a succinct answer. 1.26. What is the ratio of the Imports(as % of merchandise exports) of Grenada in 2003 to that in 2004?
Provide a succinct answer. 0.87. What is the ratio of the Imports(as % of merchandise exports) in Papua New Guinea in 2003 to that in 2004?
Offer a very short reply. 1.1. What is the ratio of the Imports(as % of merchandise exports) in Vietnam in 2003 to that in 2004?
Your response must be concise. 0.85. What is the difference between the highest and the second highest Imports(as % of merchandise exports) in Algeria?
Ensure brevity in your answer.  0.03. What is the difference between the highest and the second highest Imports(as % of merchandise exports) of Grenada?
Provide a succinct answer. 0.24. What is the difference between the highest and the second highest Imports(as % of merchandise exports) in Papua New Guinea?
Keep it short and to the point. 0.05. What is the difference between the highest and the second highest Imports(as % of merchandise exports) in Vietnam?
Provide a succinct answer. 0.43. What is the difference between the highest and the lowest Imports(as % of merchandise exports) of Algeria?
Your answer should be very brief. 0.72. What is the difference between the highest and the lowest Imports(as % of merchandise exports) of Grenada?
Offer a terse response. 0.65. What is the difference between the highest and the lowest Imports(as % of merchandise exports) of Papua New Guinea?
Your response must be concise. 0.17. What is the difference between the highest and the lowest Imports(as % of merchandise exports) in Vietnam?
Offer a very short reply. 1.32. 